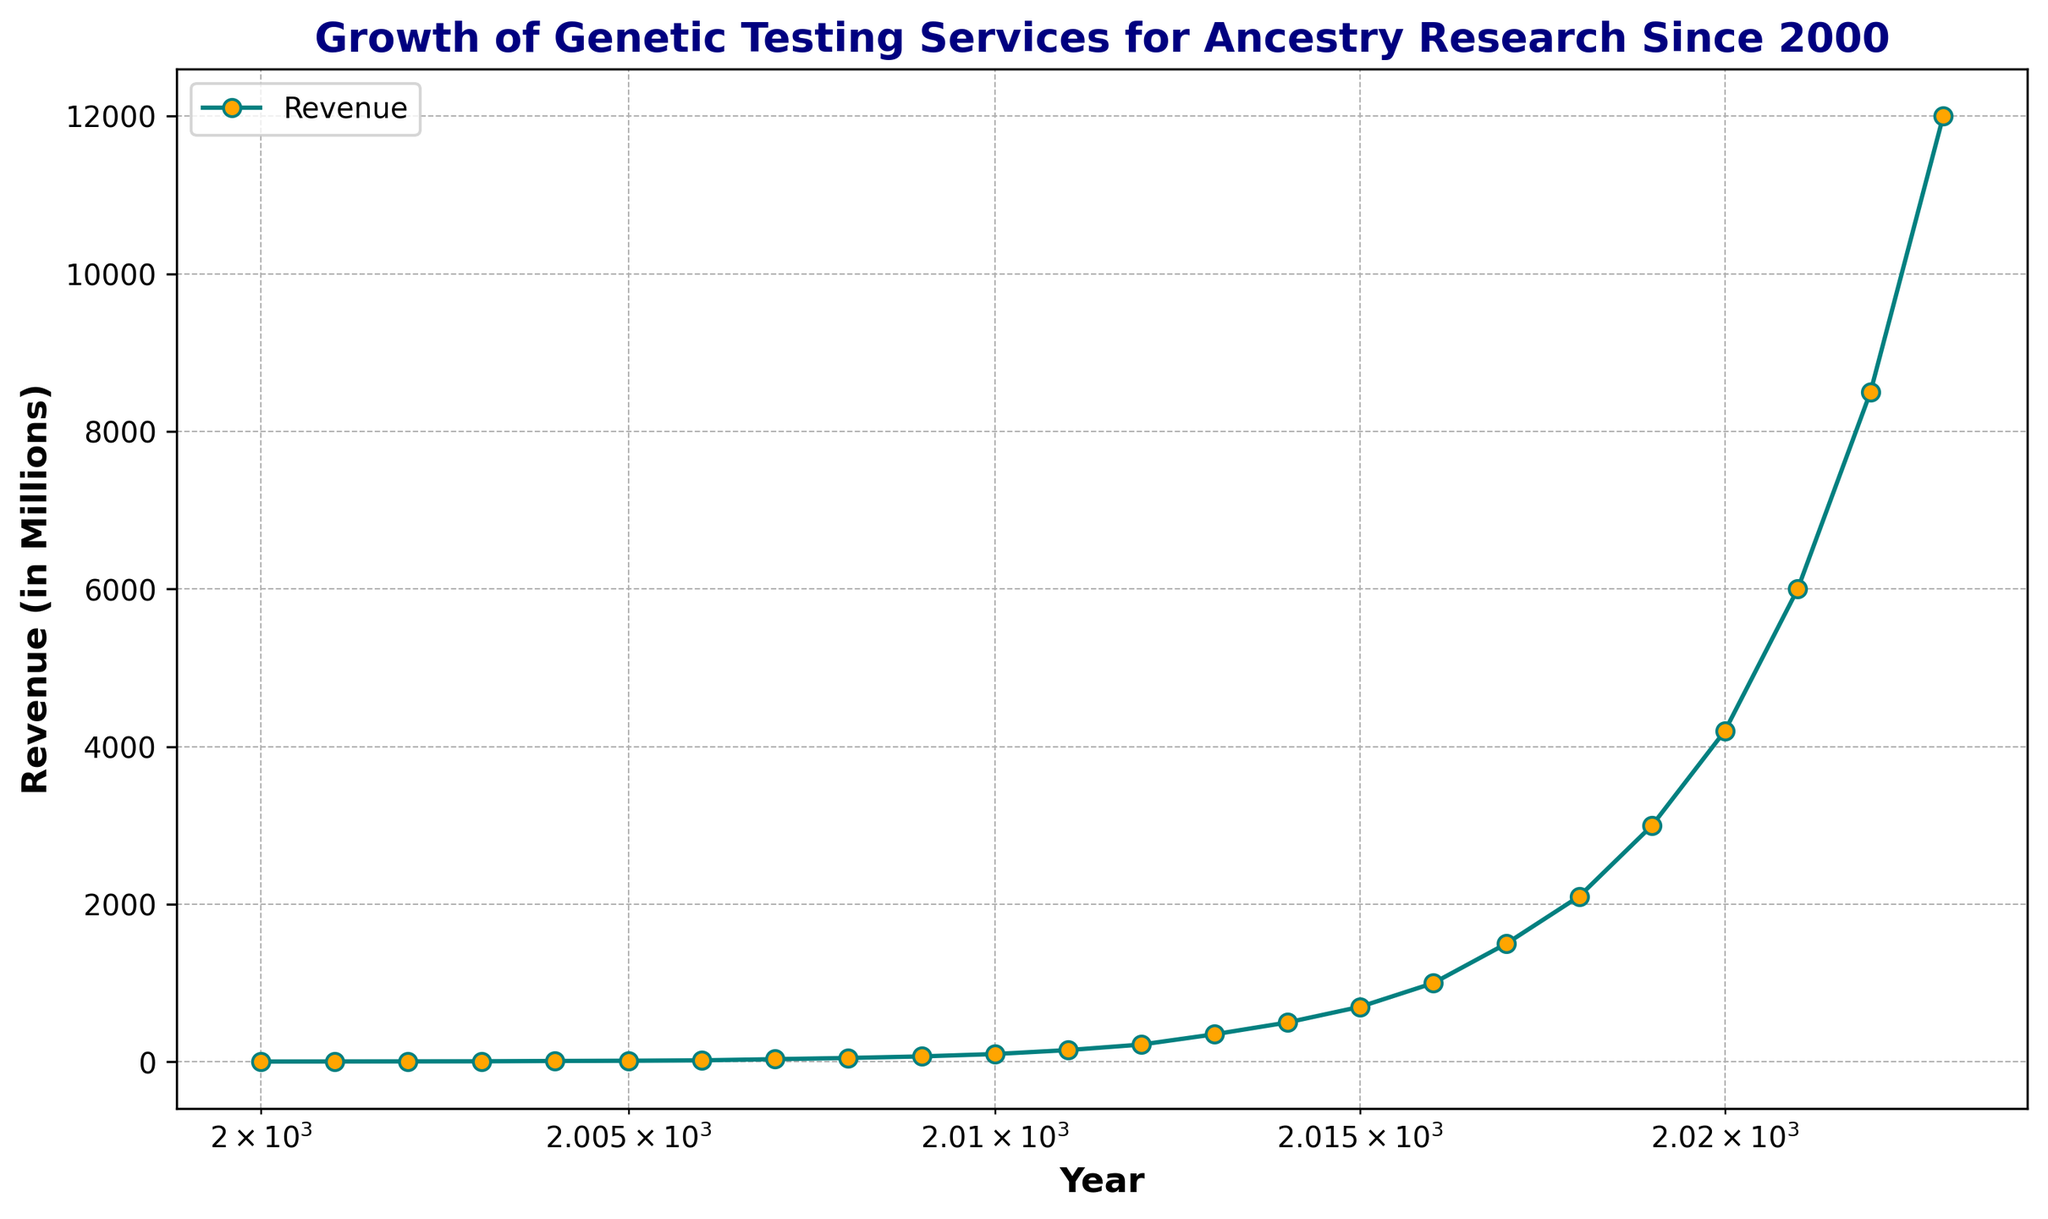What year had the revenue of 700 million? Refer to the data on the plot; look for the y-axis value of 700 million and trace it to the corresponding year on the x-axis.
Answer: 2015 What is the total revenue generated from 2020 to 2023? Sum the revenues from 2020 to 2023: 4200 + 6000 + 8500 + 12000 = 30700.
Answer: 30700 million By what factor did the revenue increase from 2000 to 2023? Divide the revenue in 2023 by the revenue in 2000. 12000 / 5 = 2400.
Answer: 2400 How much more revenue was generated in 2022 compared to 2018? Subtract the revenue in 2018 from the revenue in 2022: 8500 - 2100 = 6400.
Answer: 6400 million What year after 2010 shows the sharpest increase in revenue compared to the previous year? Identify the year with the largest difference in revenue compared to the previous year. 2020 - 2019: 1200, 2021 - 2020: 1800, 2022 - 2021: 2500, 2023 - 2022: 3500. The largest increase is between 2022 and 2023.
Answer: 2023 What was the average annual revenue from 2000 to 2005? Calculate the average of the revenues between 2000 and 2005: (5 + 6 + 7 + 8 + 12 + 15) / 6 = 8.83.
Answer: 8.83 million In which year did the revenue first exceed 1000 million? Look for the first year where the y-axis value surpasses 1000 million. According to the chart, this happens in 2016.
Answer: 2016 Compare the rate of revenue growth between the years 2011-2013 and 2019-2021. Which period had a faster growth rate? Calculate the growth rate for each period: 2013/2011 = 350/150 = 2.33 or 133% and 2021/2019 = 6000/3000 = 2 or 100%. The years 2011 to 2013 had a faster growth rate.
Answer: 2011-2013 Which decade shows the highest overall growth in revenue? Compare the total increase in revenue for each decade by summing the revenues at the beginning and end of each decade: 2010-2020: 4200 - 100 = 4100, 2020-2023: 12000 - 4200 = 7800. The highest overall growth is in the decade from 2020 to 2023.
Answer: 2020-2023 